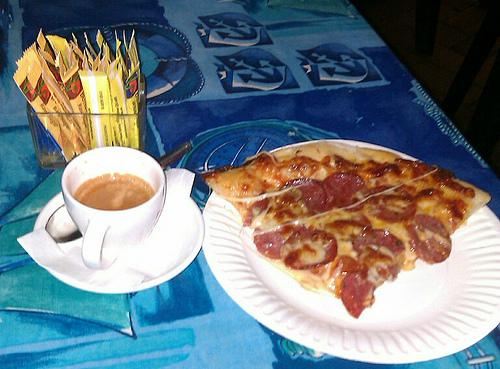Question: what food is on the table?
Choices:
A. Steak.
B. Salad.
C. Pizza.
D. Hot dogs.
Answer with the letter. Answer: C Question: why is the coffee half full?
Choices:
A. Half got poured out.
B. Someone drank half.
C. There wasn't enough to make it full.
D. Some leaked out.
Answer with the letter. Answer: B Question: where is the coffee cup?
Choices:
A. On a table.
B. In a kitchen.
C. On a saucer.
D. On a desk.
Answer with the letter. Answer: C Question: when was this taken?
Choices:
A. Dinner.
B. Lunch.
C. Mealtime.
D. Breakfast time.
Answer with the letter. Answer: C Question: who is at the table?
Choices:
A. A family.
B. A child.
C. No one.
D. A dad.
Answer with the letter. Answer: C 